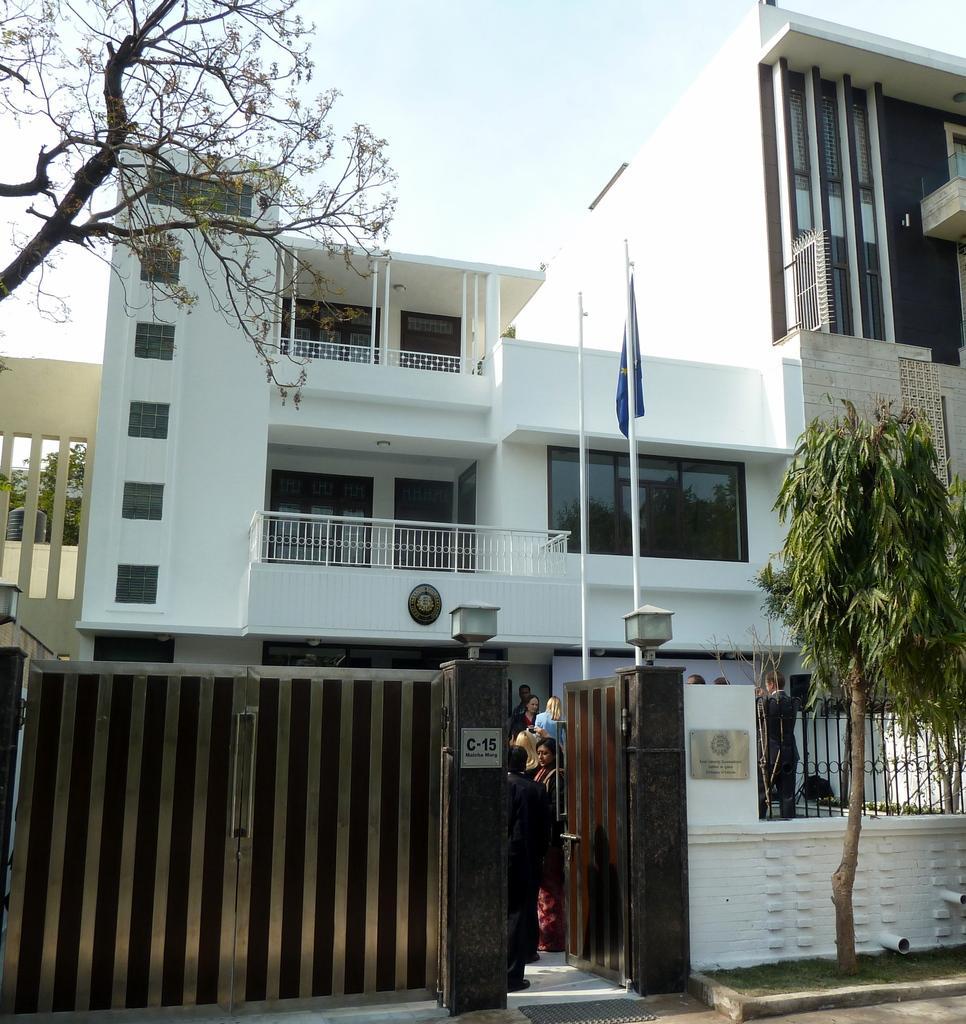How would you summarize this image in a sentence or two? This picture is clicked outside. In the foreground we can see the ground, green grass and a tree and we can see the gate and the text and numbers on the boards which are attached to the pillars and we can see the lamps and the metal rods. In the center we can see the flag, poles, railings and the windows of the building and we can see the group of people seems to be standing on the ground and there is an object hanging on the wall of the building. In the background we can see the sky, trees, a black color object which seems to be the tanker. In the top left corner we can see the tree. 